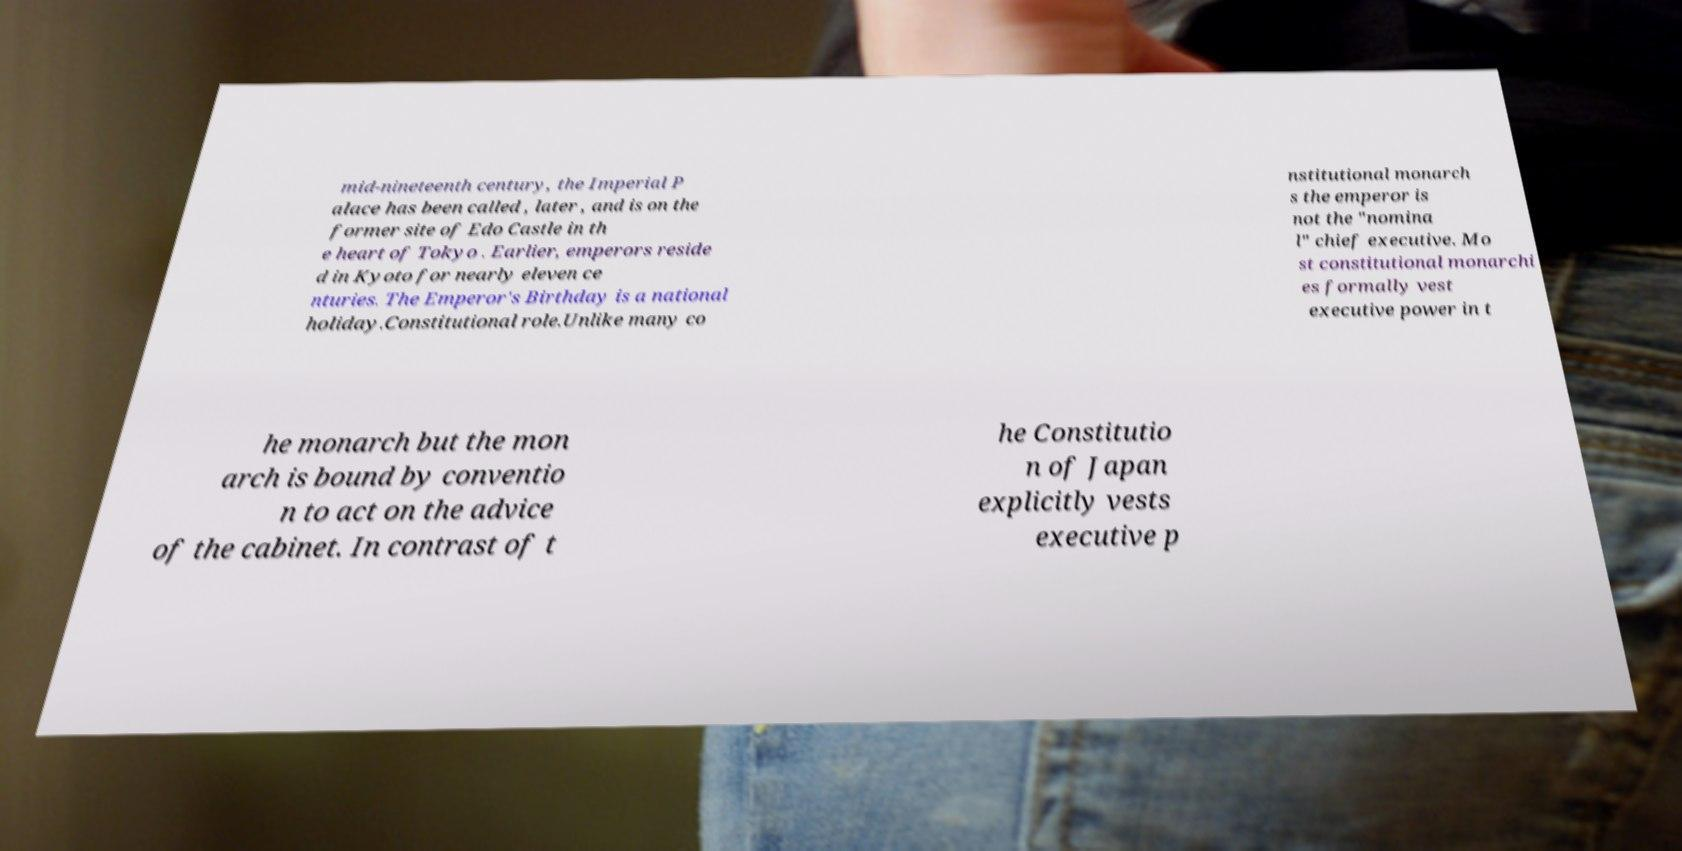Can you accurately transcribe the text from the provided image for me? mid-nineteenth century, the Imperial P alace has been called , later , and is on the former site of Edo Castle in th e heart of Tokyo . Earlier, emperors reside d in Kyoto for nearly eleven ce nturies. The Emperor's Birthday is a national holiday.Constitutional role.Unlike many co nstitutional monarch s the emperor is not the "nomina l" chief executive. Mo st constitutional monarchi es formally vest executive power in t he monarch but the mon arch is bound by conventio n to act on the advice of the cabinet. In contrast of t he Constitutio n of Japan explicitly vests executive p 